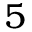<formula> <loc_0><loc_0><loc_500><loc_500>5</formula> 